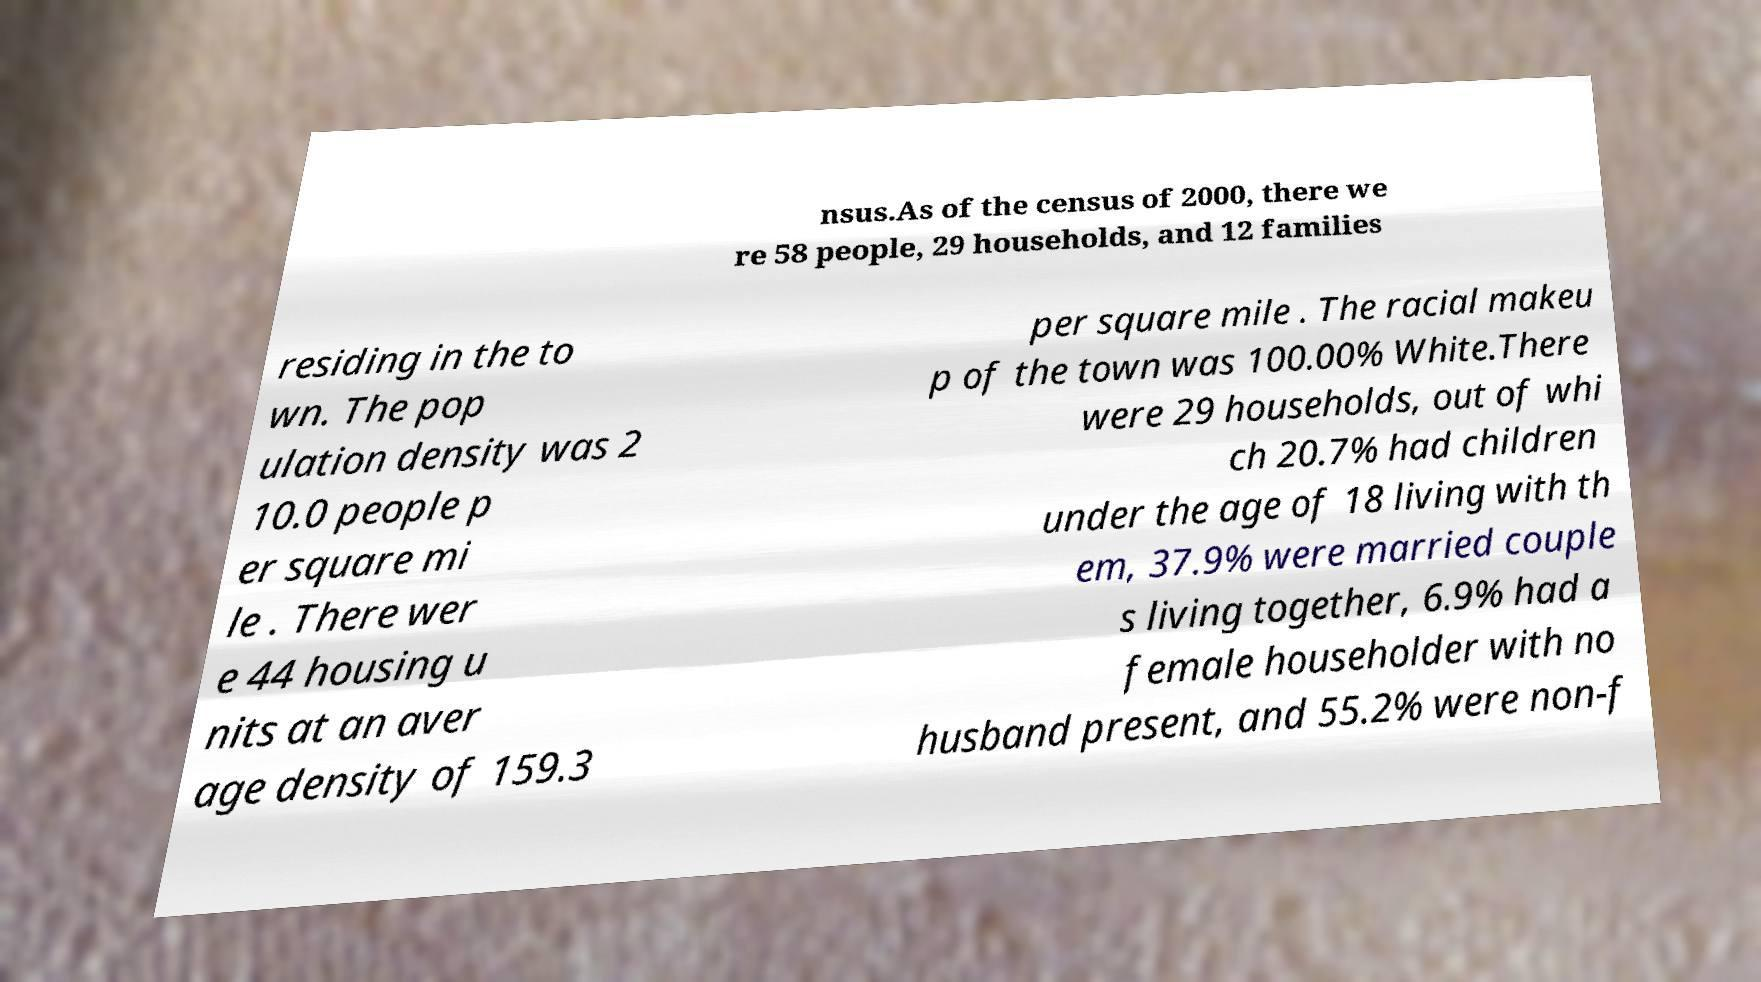I need the written content from this picture converted into text. Can you do that? nsus.As of the census of 2000, there we re 58 people, 29 households, and 12 families residing in the to wn. The pop ulation density was 2 10.0 people p er square mi le . There wer e 44 housing u nits at an aver age density of 159.3 per square mile . The racial makeu p of the town was 100.00% White.There were 29 households, out of whi ch 20.7% had children under the age of 18 living with th em, 37.9% were married couple s living together, 6.9% had a female householder with no husband present, and 55.2% were non-f 